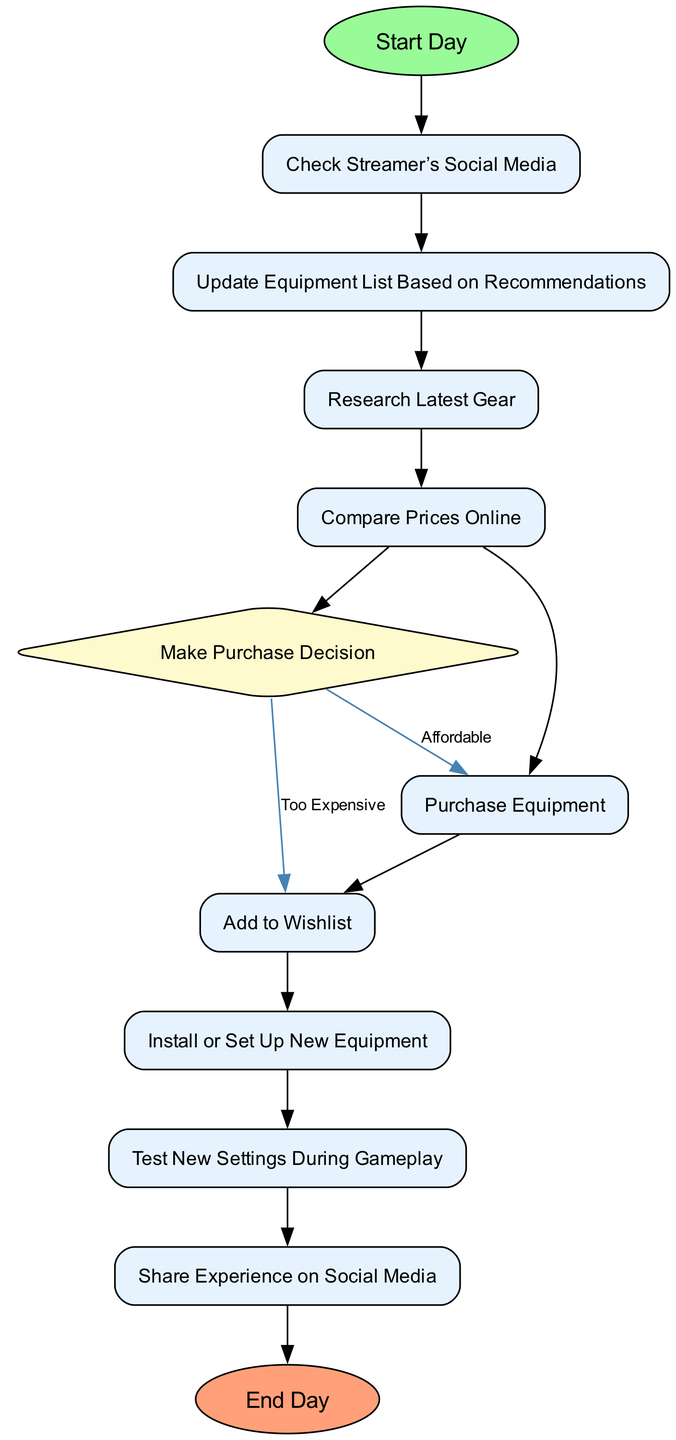What is the first action in the diagram? The first action in the diagram is labeled "Start Day," which is the starting point of the routine for following the streamer's recommendations.
Answer: Start Day How many actions are listed in the diagram? There are ten actions listed in the diagram that describe various steps taken throughout the day.
Answer: 10 What happens after checking the streamer’s social media? After checking the streamer’s social media, the next step is to "Update Equipment List Based on Recommendations," showing a direct flow from one activity to the next.
Answer: Update Equipment List Based on Recommendations How many decision points are present in the diagram? The diagram contains one decision point, which is represented by the "Make Purchase Decision" node where the flow can diverge based on affordability.
Answer: 1 If the equipment is listed as "Affordable," what is the next step? If the equipment is "Affordable," the next step is "Purchase Equipment," indicating a clear path of action following the decision point.
Answer: Purchase Equipment What action follows after the installation or setup of new equipment? After "Install or Set Up New Equipment," the next action is "Test New Settings During Gameplay," indicating a sequence of testing post-setup.
Answer: Test New Settings During Gameplay What happens if the equipment is "Too Expensive"? If the equipment is deemed "Too Expensive," the flow directs to "Add to Wishlist," showing an alternative plan when the purchase is not feasible.
Answer: Add to Wishlist How does the diagram end? The diagram ends with the activity labeled "End Day," marking the conclusion of the daily routine for following the streamer's recommendations.
Answer: End Day Which action involves sharing experiences? The action that involves sharing experiences is "Share Experience on Social Media," highlighting the importance of community engagement in the routine.
Answer: Share Experience on Social Media 